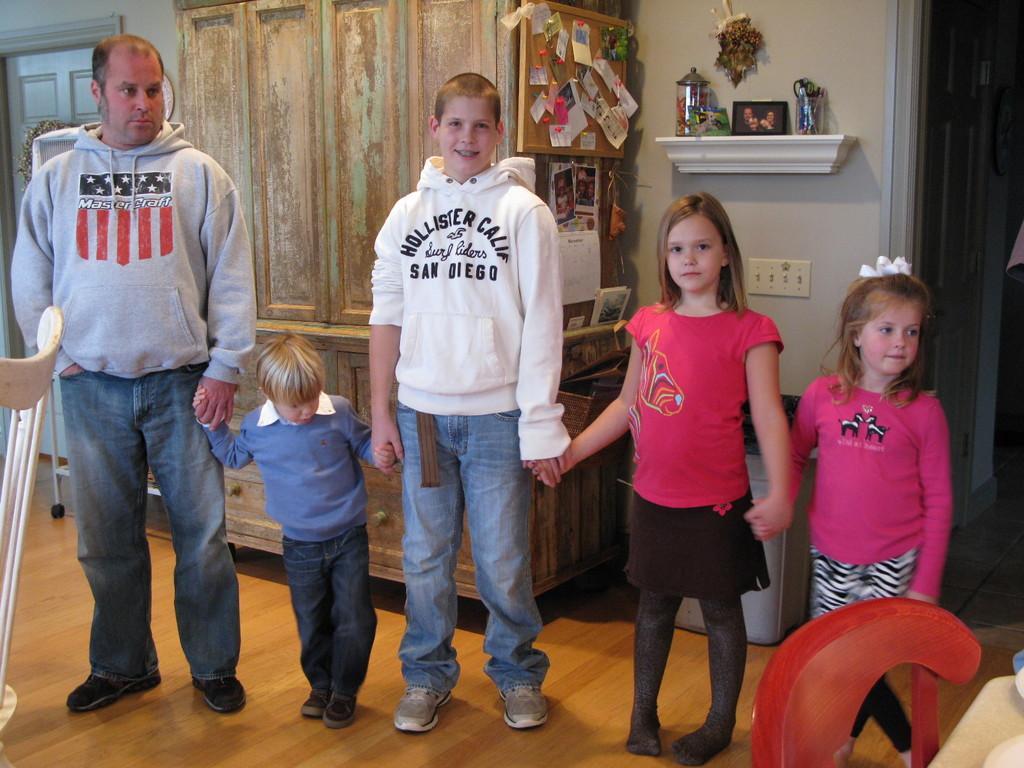Describe this image in one or two sentences. In this picture we can see some persons standing on the floor. On the background there is a cupboard. This is floor. And there is a wall. 